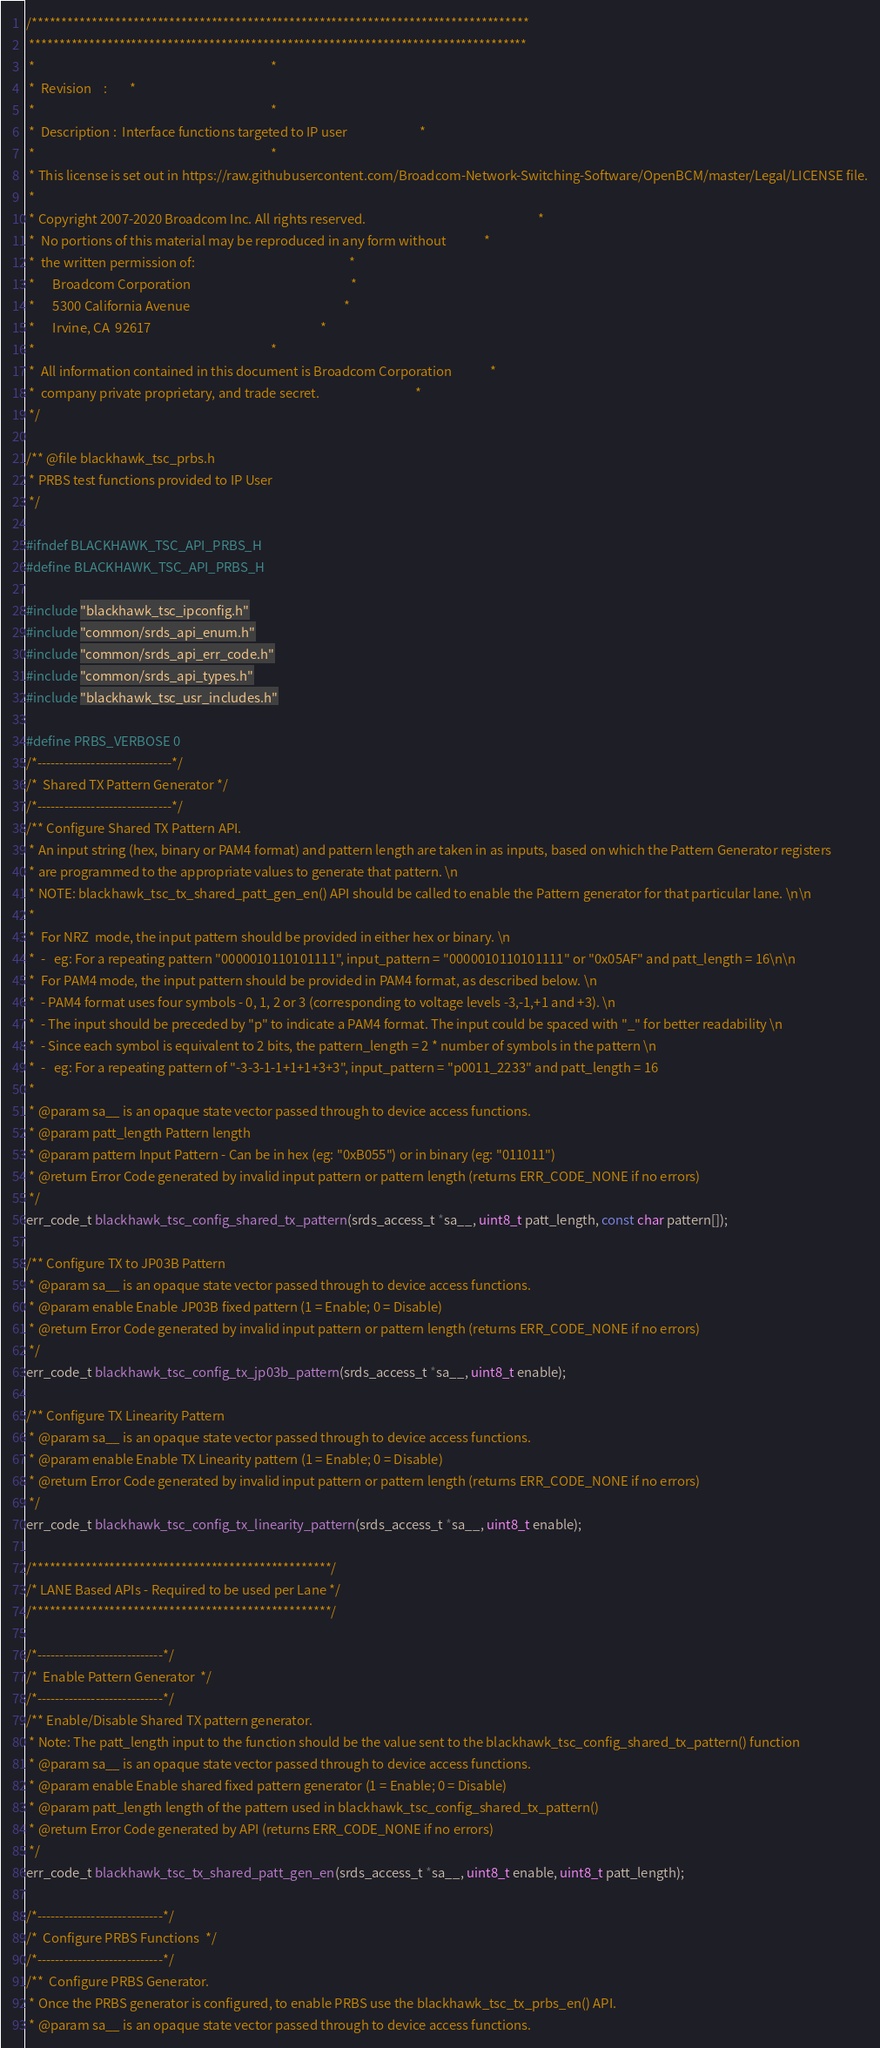<code> <loc_0><loc_0><loc_500><loc_500><_C_>/***********************************************************************************
 ***********************************************************************************
 *                                                                                 *
 *  Revision    :        *
 *                                                                                 *
 *  Description :  Interface functions targeted to IP user                         *
 *                                                                                 *
 * This license is set out in https://raw.githubusercontent.com/Broadcom-Network-Switching-Software/OpenBCM/master/Legal/LICENSE file.
 * 
 * Copyright 2007-2020 Broadcom Inc. All rights reserved.                                                           *
 *  No portions of this material may be reproduced in any form without             *
 *  the written permission of:                                                     *
 *      Broadcom Corporation                                                       *
 *      5300 California Avenue                                                     *
 *      Irvine, CA  92617                                                          *
 *                                                                                 *
 *  All information contained in this document is Broadcom Corporation             *
 *  company private proprietary, and trade secret.                                 *
 */

/** @file blackhawk_tsc_prbs.h
 * PRBS test functions provided to IP User
 */

#ifndef BLACKHAWK_TSC_API_PRBS_H
#define BLACKHAWK_TSC_API_PRBS_H

#include "blackhawk_tsc_ipconfig.h"
#include "common/srds_api_enum.h"
#include "common/srds_api_err_code.h"
#include "common/srds_api_types.h"
#include "blackhawk_tsc_usr_includes.h"

#define PRBS_VERBOSE 0
/*------------------------------*/
/*  Shared TX Pattern Generator */
/*------------------------------*/
/** Configure Shared TX Pattern API.
 * An input string (hex, binary or PAM4 format) and pattern length are taken in as inputs, based on which the Pattern Generator registers
 * are programmed to the appropriate values to generate that pattern. \n
 * NOTE: blackhawk_tsc_tx_shared_patt_gen_en() API should be called to enable the Pattern generator for that particular lane. \n\n
 *
 *  For NRZ  mode, the input pattern should be provided in either hex or binary. \n
 *  -   eg: For a repeating pattern "0000010110101111", input_pattern = "0000010110101111" or "0x05AF" and patt_length = 16\n\n
 *  For PAM4 mode, the input pattern should be provided in PAM4 format, as described below. \n
 *  - PAM4 format uses four symbols - 0, 1, 2 or 3 (corresponding to voltage levels -3,-1,+1 and +3). \n
 *  - The input should be preceded by "p" to indicate a PAM4 format. The input could be spaced with "_" for better readability \n
 *  - Since each symbol is equivalent to 2 bits, the pattern_length = 2 * number of symbols in the pattern \n
 *  -   eg: For a repeating pattern of "-3-3-1-1+1+1+3+3", input_pattern = "p0011_2233" and patt_length = 16
 *
 * @param sa__ is an opaque state vector passed through to device access functions.
 * @param patt_length Pattern length
 * @param pattern Input Pattern - Can be in hex (eg: "0xB055") or in binary (eg: "011011")
 * @return Error Code generated by invalid input pattern or pattern length (returns ERR_CODE_NONE if no errors)
 */
err_code_t blackhawk_tsc_config_shared_tx_pattern(srds_access_t *sa__, uint8_t patt_length, const char pattern[]);

/** Configure TX to JP03B Pattern
 * @param sa__ is an opaque state vector passed through to device access functions.
 * @param enable Enable JP03B fixed pattern (1 = Enable; 0 = Disable)
 * @return Error Code generated by invalid input pattern or pattern length (returns ERR_CODE_NONE if no errors)
 */
err_code_t blackhawk_tsc_config_tx_jp03b_pattern(srds_access_t *sa__, uint8_t enable);

/** Configure TX Linearity Pattern
 * @param sa__ is an opaque state vector passed through to device access functions.
 * @param enable Enable TX Linearity pattern (1 = Enable; 0 = Disable)
 * @return Error Code generated by invalid input pattern or pattern length (returns ERR_CODE_NONE if no errors)
 */
err_code_t blackhawk_tsc_config_tx_linearity_pattern(srds_access_t *sa__, uint8_t enable);

/**************************************************/
/* LANE Based APIs - Required to be used per Lane */
/**************************************************/

/*----------------------------*/
/*  Enable Pattern Generator  */
/*----------------------------*/
/** Enable/Disable Shared TX pattern generator.
 * Note: The patt_length input to the function should be the value sent to the blackhawk_tsc_config_shared_tx_pattern() function
 * @param sa__ is an opaque state vector passed through to device access functions.
 * @param enable Enable shared fixed pattern generator (1 = Enable; 0 = Disable)
 * @param patt_length length of the pattern used in blackhawk_tsc_config_shared_tx_pattern()
 * @return Error Code generated by API (returns ERR_CODE_NONE if no errors)
 */
err_code_t blackhawk_tsc_tx_shared_patt_gen_en(srds_access_t *sa__, uint8_t enable, uint8_t patt_length);

/*----------------------------*/
/*  Configure PRBS Functions  */
/*----------------------------*/
/**  Configure PRBS Generator.
 * Once the PRBS generator is configured, to enable PRBS use the blackhawk_tsc_tx_prbs_en() API.
 * @param sa__ is an opaque state vector passed through to device access functions.</code> 